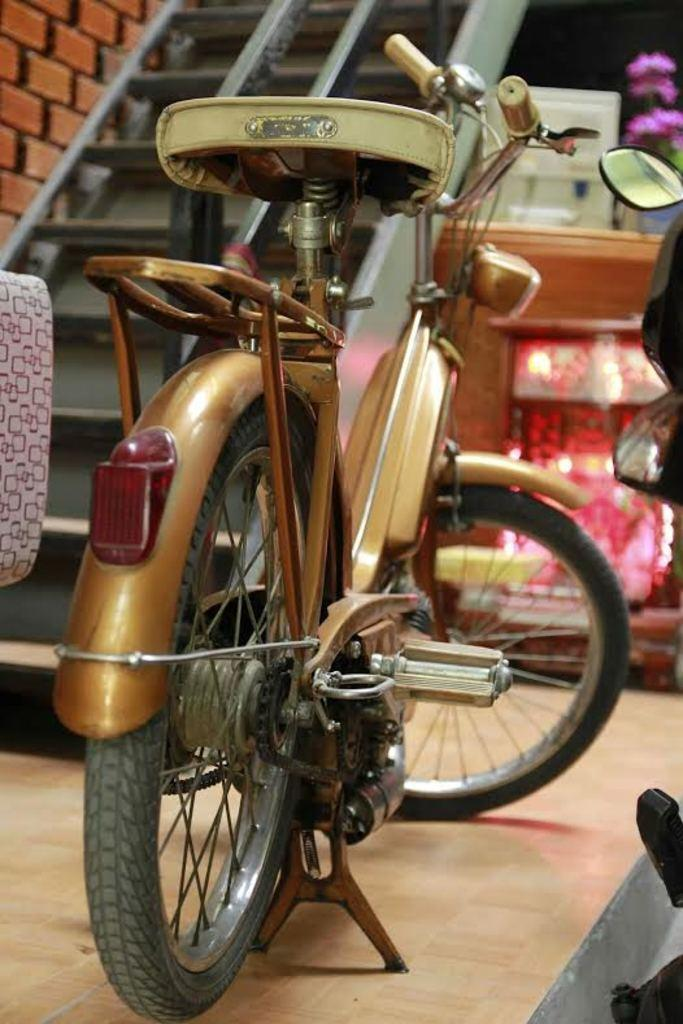What is the main object in the image? There is a bicycle in the image. Where is the bicycle located? The bicycle is on a path. What is in front of the bicycle? There is a staircase and a mirror in front of the bicycle, as well as other unspecified things. How many trees can be seen running alongside the bicycle in the image? There are no trees visible in the image, and trees cannot run. 